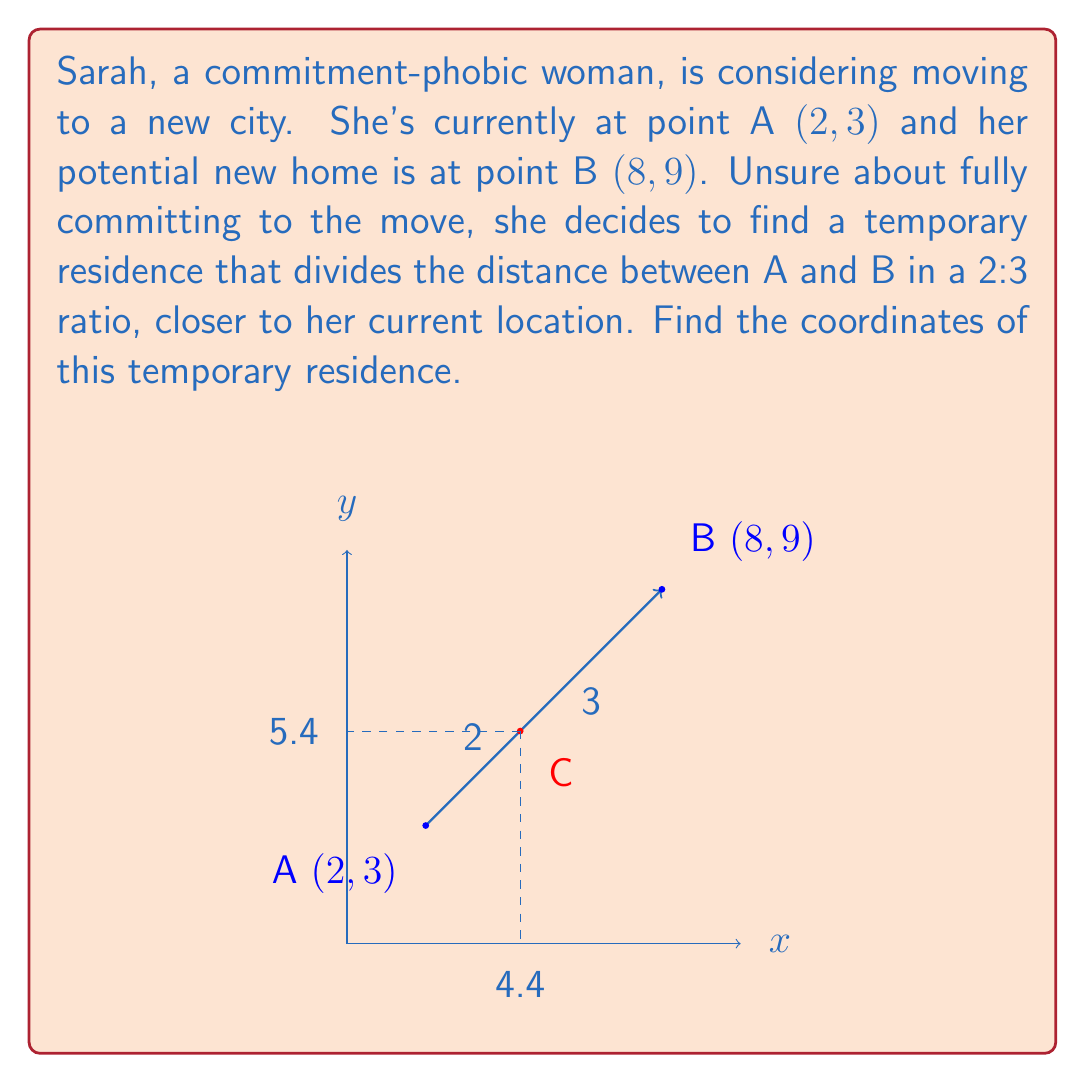Can you solve this math problem? Let's solve this step-by-step:

1) The ratio we're looking for is 2:3, with the point being closer to A. This means we need to divide the line segment AB in the ratio 2:5 (2+3=5).

2) We can use the section formula:
   $$(x,y) = \left(\frac{m x_2 + n x_1}{m+n}, \frac{m y_2 + n y_1}{m+n}\right)$$
   where $(x_1,y_1)$ is point A, $(x_2,y_2)$ is point B, and $m:n$ is our ratio.

3) In this case:
   $(x_1,y_1) = (2,3)$
   $(x_2,y_2) = (8,9)$
   $m = 3$ and $n = 2$ (because the point is closer to A)

4) Let's calculate x-coordinate:
   $$x = \frac{3(8) + 2(2)}{3+2} = \frac{24 + 4}{5} = \frac{28}{5} = 5.6$$

5) Now, y-coordinate:
   $$y = \frac{3(9) + 2(3)}{3+2} = \frac{27 + 6}{5} = \frac{33}{5} = 6.6$$

6) Therefore, the coordinates of the temporary residence are (5.6, 6.6).
Answer: (5.6, 6.6) 